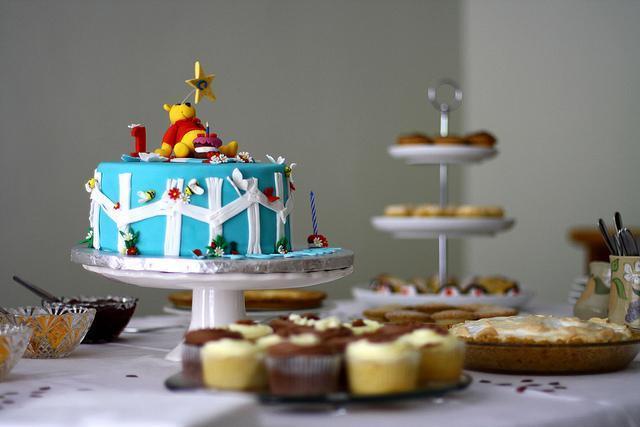Is the caption "The dining table is touching the teddy bear." a true representation of the image?
Answer yes or no. No. Is the given caption "The dining table is beneath the teddy bear." fitting for the image?
Answer yes or no. Yes. 